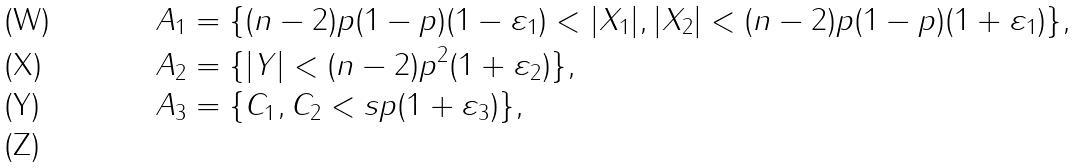Convert formula to latex. <formula><loc_0><loc_0><loc_500><loc_500>A _ { 1 } & = \{ ( n - 2 ) p ( 1 - p ) ( 1 - \varepsilon _ { 1 } ) < | X _ { 1 } | , | X _ { 2 } | < ( n - 2 ) p ( 1 - p ) ( 1 + \varepsilon _ { 1 } ) \} , \\ A _ { 2 } & = \{ | Y | < ( n - 2 ) p ^ { 2 } ( 1 + \varepsilon _ { 2 } ) \} , \\ A _ { 3 } & = \{ C _ { 1 } , C _ { 2 } < s p ( 1 + \varepsilon _ { 3 } ) \} , \\</formula> 